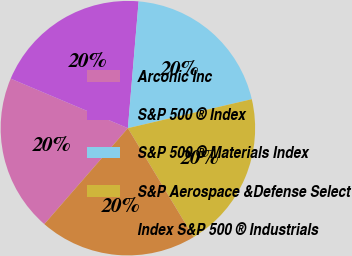<chart> <loc_0><loc_0><loc_500><loc_500><pie_chart><fcel>Arconic Inc<fcel>S&P 500 ® Index<fcel>S&P 500 ® Materials Index<fcel>S&P Aerospace &Defense Select<fcel>Index S&P 500 ® Industrials<nl><fcel>19.96%<fcel>19.98%<fcel>20.0%<fcel>20.02%<fcel>20.04%<nl></chart> 